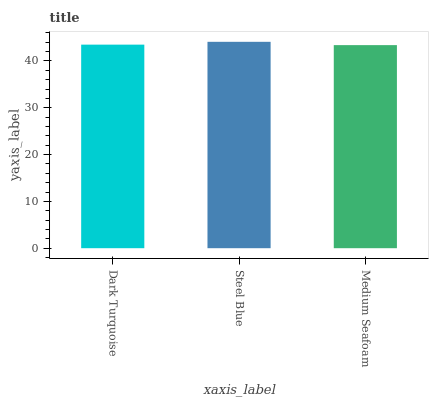Is Medium Seafoam the minimum?
Answer yes or no. Yes. Is Steel Blue the maximum?
Answer yes or no. Yes. Is Steel Blue the minimum?
Answer yes or no. No. Is Medium Seafoam the maximum?
Answer yes or no. No. Is Steel Blue greater than Medium Seafoam?
Answer yes or no. Yes. Is Medium Seafoam less than Steel Blue?
Answer yes or no. Yes. Is Medium Seafoam greater than Steel Blue?
Answer yes or no. No. Is Steel Blue less than Medium Seafoam?
Answer yes or no. No. Is Dark Turquoise the high median?
Answer yes or no. Yes. Is Dark Turquoise the low median?
Answer yes or no. Yes. Is Medium Seafoam the high median?
Answer yes or no. No. Is Steel Blue the low median?
Answer yes or no. No. 